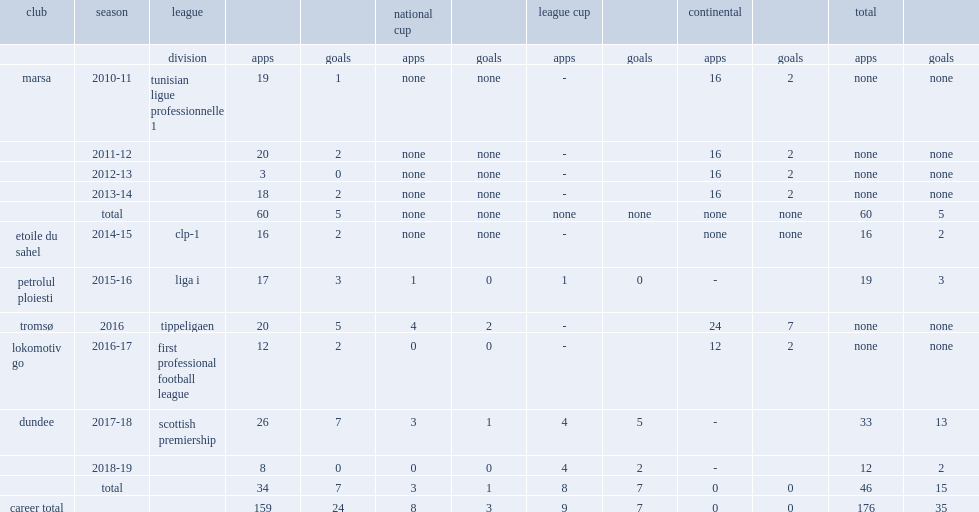Which club did moussa play for in the 2015-16 season? Petrolul ploiesti. 